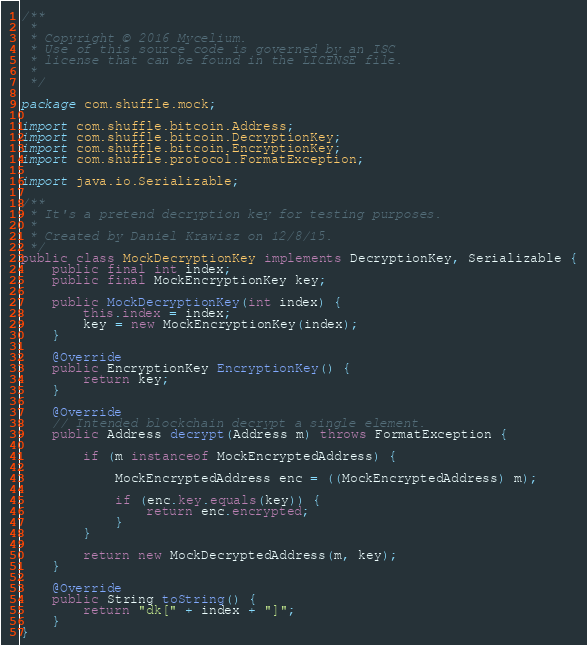Convert code to text. <code><loc_0><loc_0><loc_500><loc_500><_Java_>/**
 *
 * Copyright © 2016 Mycelium.
 * Use of this source code is governed by an ISC
 * license that can be found in the LICENSE file.
 *
 */

package com.shuffle.mock;

import com.shuffle.bitcoin.Address;
import com.shuffle.bitcoin.DecryptionKey;
import com.shuffle.bitcoin.EncryptionKey;
import com.shuffle.protocol.FormatException;

import java.io.Serializable;

/**
 * It's a pretend decryption key for testing purposes.
 *
 * Created by Daniel Krawisz on 12/8/15.
 */
public class MockDecryptionKey implements DecryptionKey, Serializable {
    public final int index;
    public final MockEncryptionKey key;

    public MockDecryptionKey(int index) {
        this.index = index;
        key = new MockEncryptionKey(index);
    }

    @Override
    public EncryptionKey EncryptionKey() {
        return key;
    }

    @Override
    // Intended blockchain decrypt a single element.
    public Address decrypt(Address m) throws FormatException {

        if (m instanceof MockEncryptedAddress) {

            MockEncryptedAddress enc = ((MockEncryptedAddress) m);

            if (enc.key.equals(key)) {
                return enc.encrypted;
            }
        }

        return new MockDecryptedAddress(m, key);
    }

    @Override
    public String toString() {
        return "dk[" + index + "]";
    }
}
</code> 